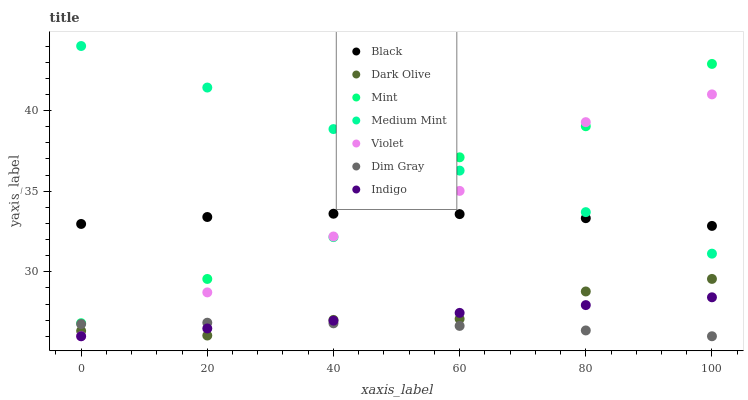Does Dim Gray have the minimum area under the curve?
Answer yes or no. Yes. Does Medium Mint have the maximum area under the curve?
Answer yes or no. Yes. Does Indigo have the minimum area under the curve?
Answer yes or no. No. Does Indigo have the maximum area under the curve?
Answer yes or no. No. Is Indigo the smoothest?
Answer yes or no. Yes. Is Mint the roughest?
Answer yes or no. Yes. Is Dim Gray the smoothest?
Answer yes or no. No. Is Dim Gray the roughest?
Answer yes or no. No. Does Dim Gray have the lowest value?
Answer yes or no. Yes. Does Dark Olive have the lowest value?
Answer yes or no. No. Does Medium Mint have the highest value?
Answer yes or no. Yes. Does Indigo have the highest value?
Answer yes or no. No. Is Dim Gray less than Medium Mint?
Answer yes or no. Yes. Is Mint greater than Dim Gray?
Answer yes or no. Yes. Does Dark Olive intersect Violet?
Answer yes or no. Yes. Is Dark Olive less than Violet?
Answer yes or no. No. Is Dark Olive greater than Violet?
Answer yes or no. No. Does Dim Gray intersect Medium Mint?
Answer yes or no. No. 